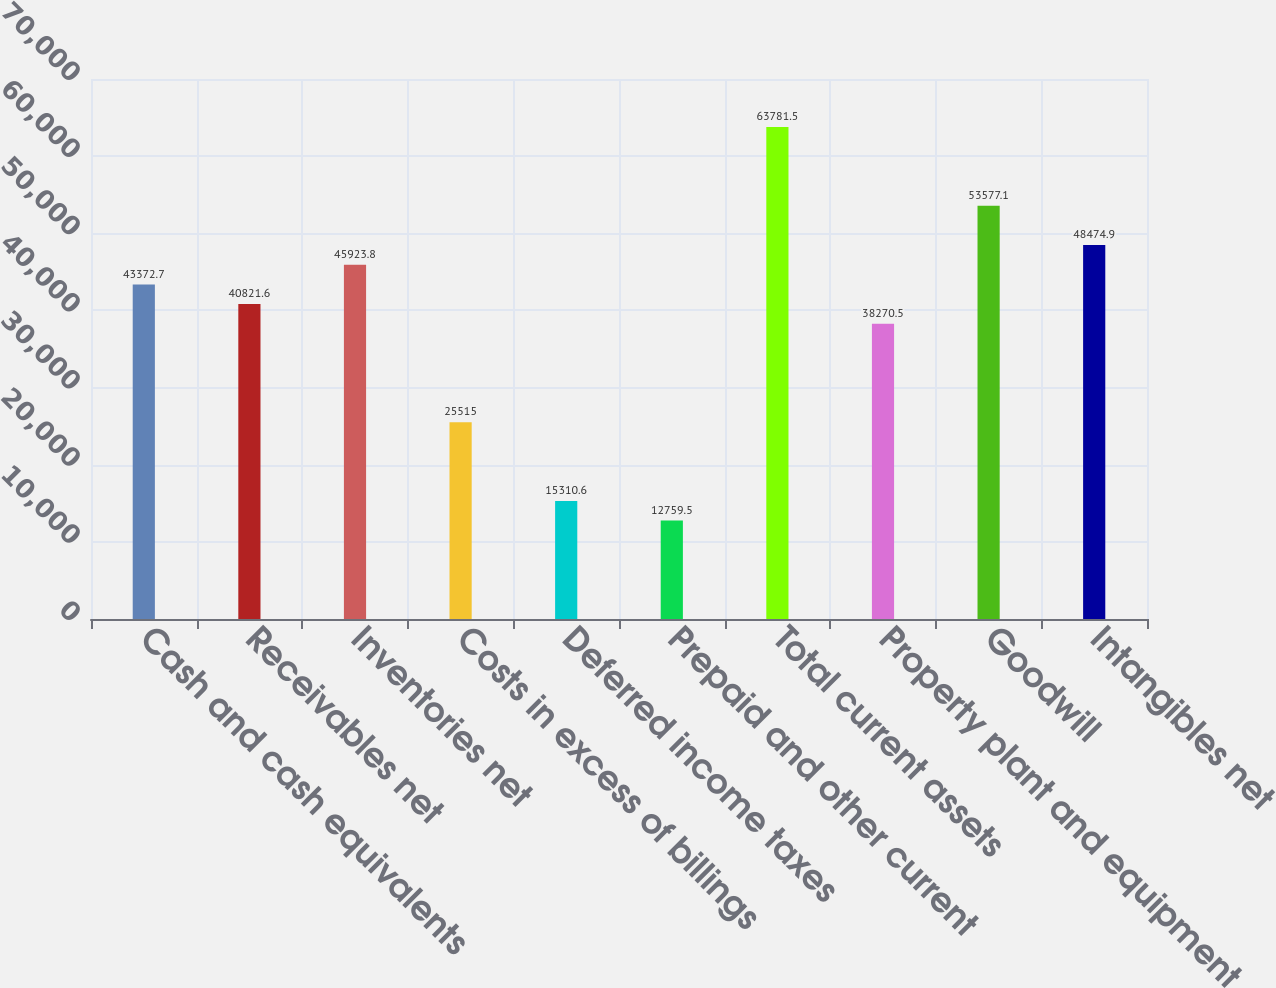Convert chart. <chart><loc_0><loc_0><loc_500><loc_500><bar_chart><fcel>Cash and cash equivalents<fcel>Receivables net<fcel>Inventories net<fcel>Costs in excess of billings<fcel>Deferred income taxes<fcel>Prepaid and other current<fcel>Total current assets<fcel>Property plant and equipment<fcel>Goodwill<fcel>Intangibles net<nl><fcel>43372.7<fcel>40821.6<fcel>45923.8<fcel>25515<fcel>15310.6<fcel>12759.5<fcel>63781.5<fcel>38270.5<fcel>53577.1<fcel>48474.9<nl></chart> 